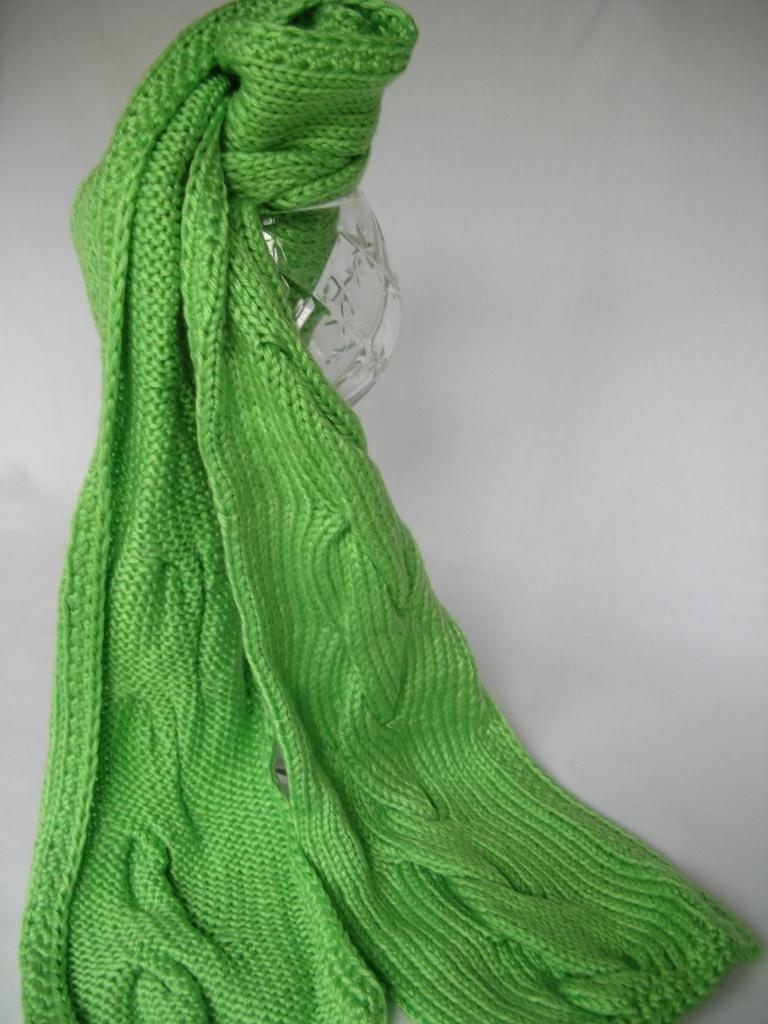What object is the main focus of the image? There is a glass jar in the image. Can you describe the color of the glass jar? The glass jar appears to be green in color. What can be seen in the background of the image? The background of the image is white. Are there any icicles hanging from the glass jar in the image? There are no icicles present in the image; it only features a green glass jar against a white background. What type of quartz can be seen in the image? There is no quartz present in the image. 